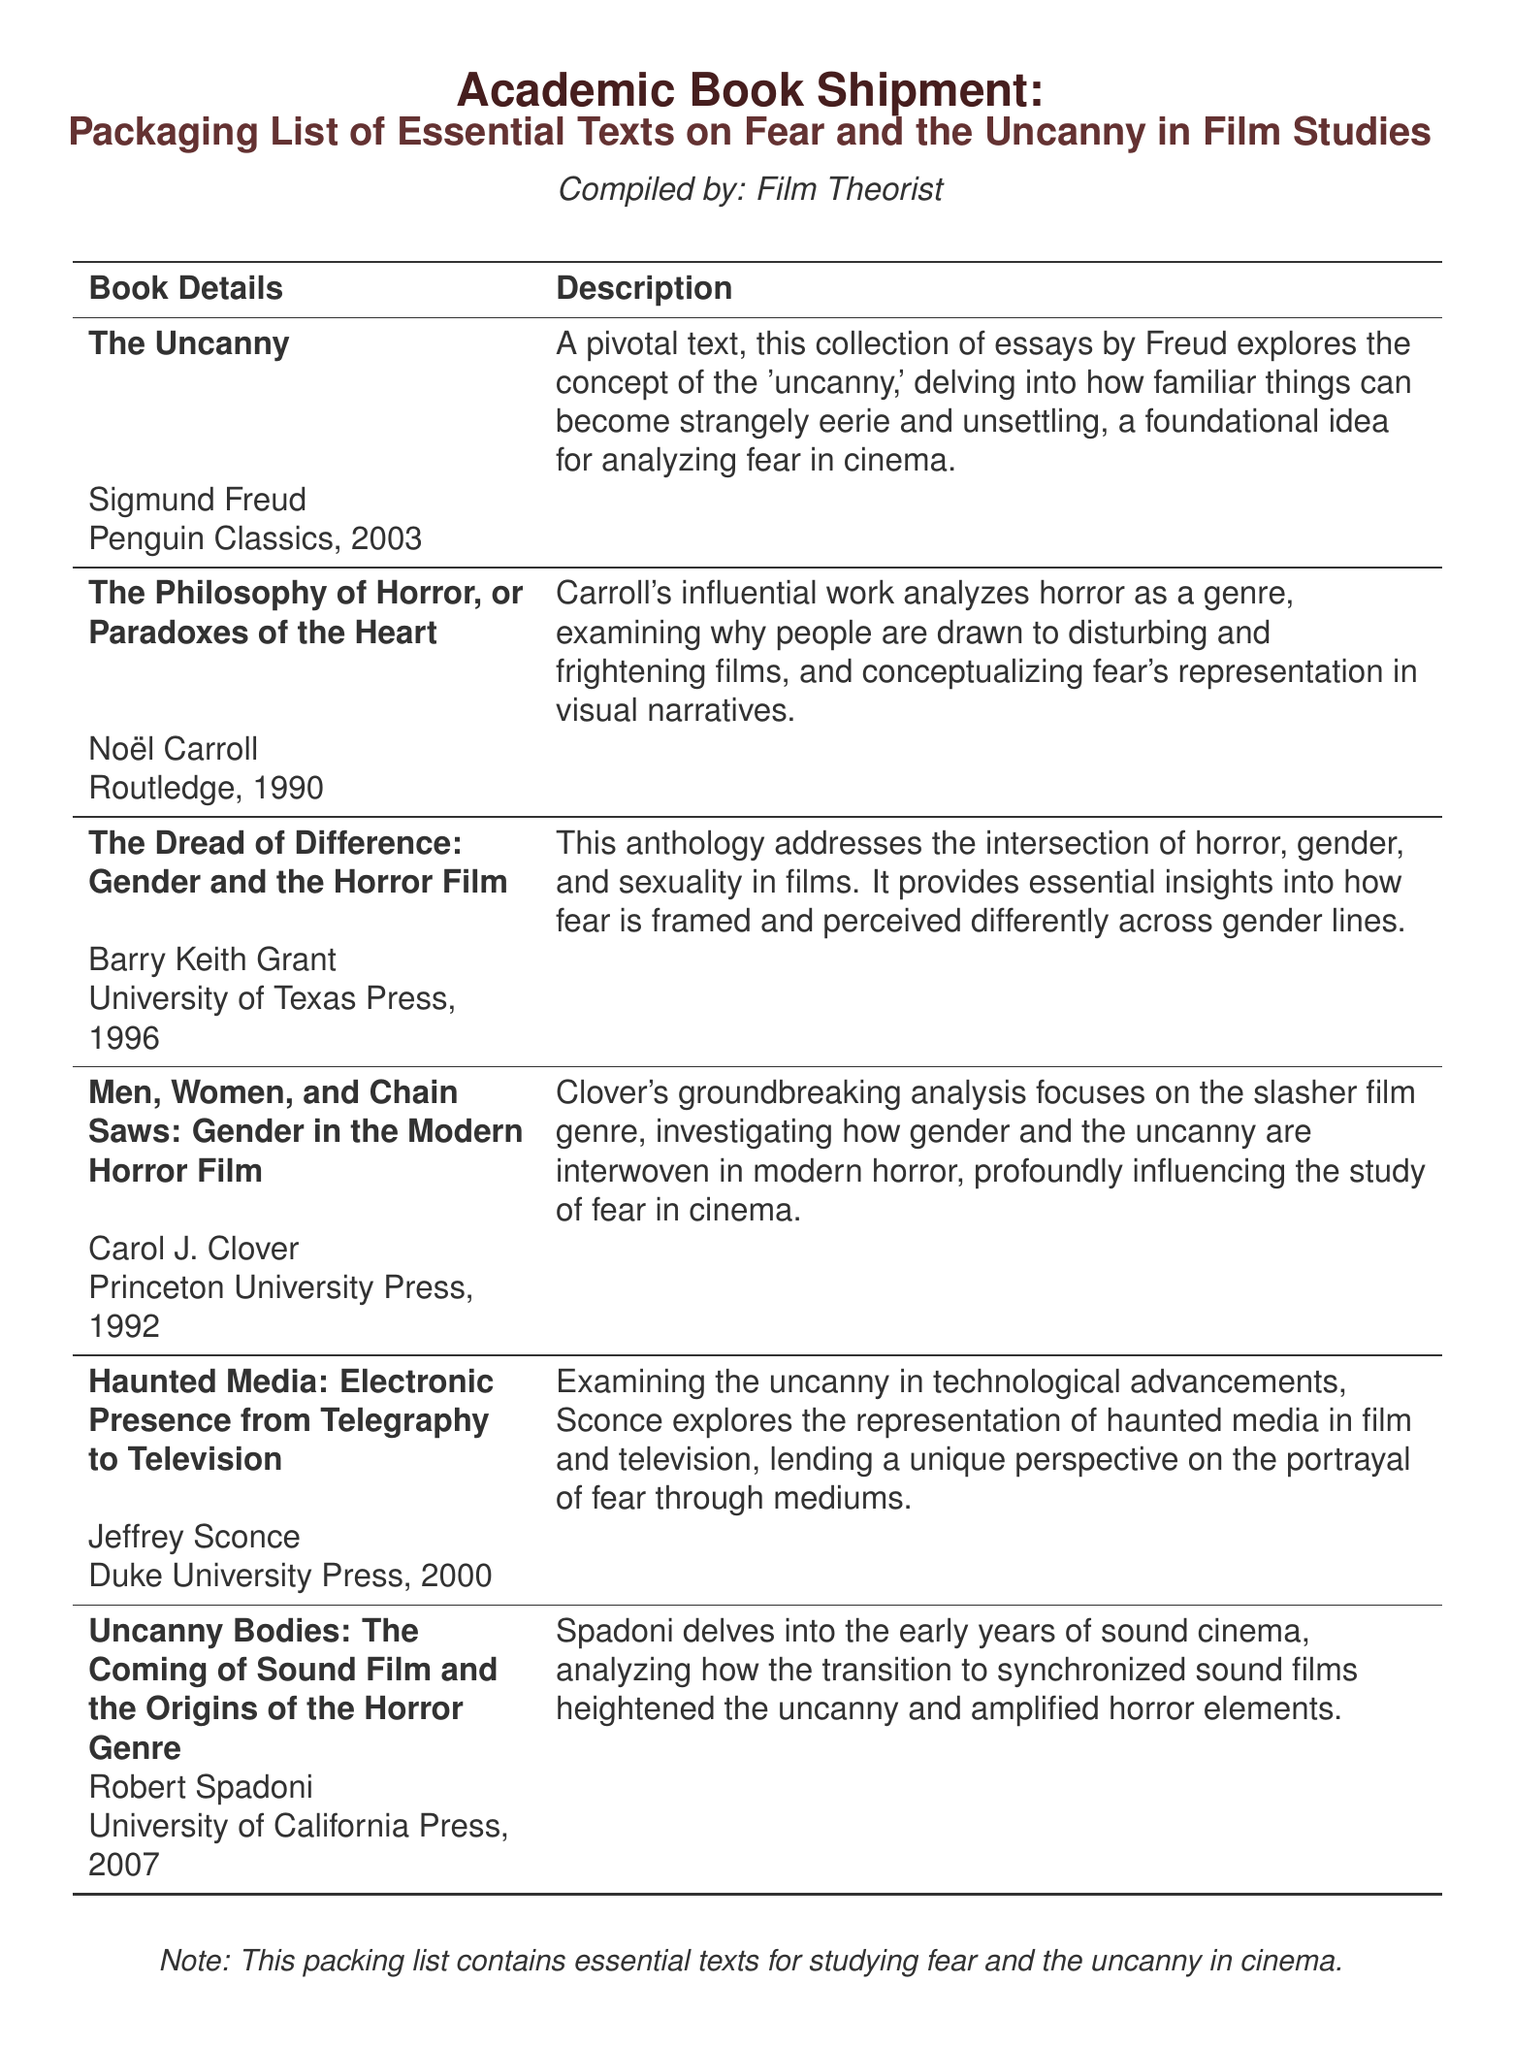What is the name of the first book in the list? The first book listed is 'The Uncanny' by Sigmund Freud.
Answer: The Uncanny Who is the author of 'Men, Women, and Chain Saws'? The author of this book is Carol J. Clover.
Answer: Carol J. Clover In what year was 'The Philosophy of Horror' published? This book was published in 1990.
Answer: 1990 What is the main focus of 'The Dread of Difference'? The main focus is on the intersection of horror, gender, and sexuality in films.
Answer: Gender and Horror How many books are listed in the packing list? There are six essential texts mentioned in the packaging list.
Answer: Six Which publisher released 'Haunted Media'? The publisher of this book is Duke University Press.
Answer: Duke University Press What critical concept does Freud's 'The Uncanny' explore? The critical concept explored is the notion of the uncanny, unsettling familiar things.
Answer: The uncanny What genre does 'Men, Women, and Chain Saws' specifically analyze? This book specifically analyzes the slasher film genre.
Answer: Slasher film genre Who compiled the packaging list? The packing list was compiled by a Film Theorist.
Answer: Film Theorist 